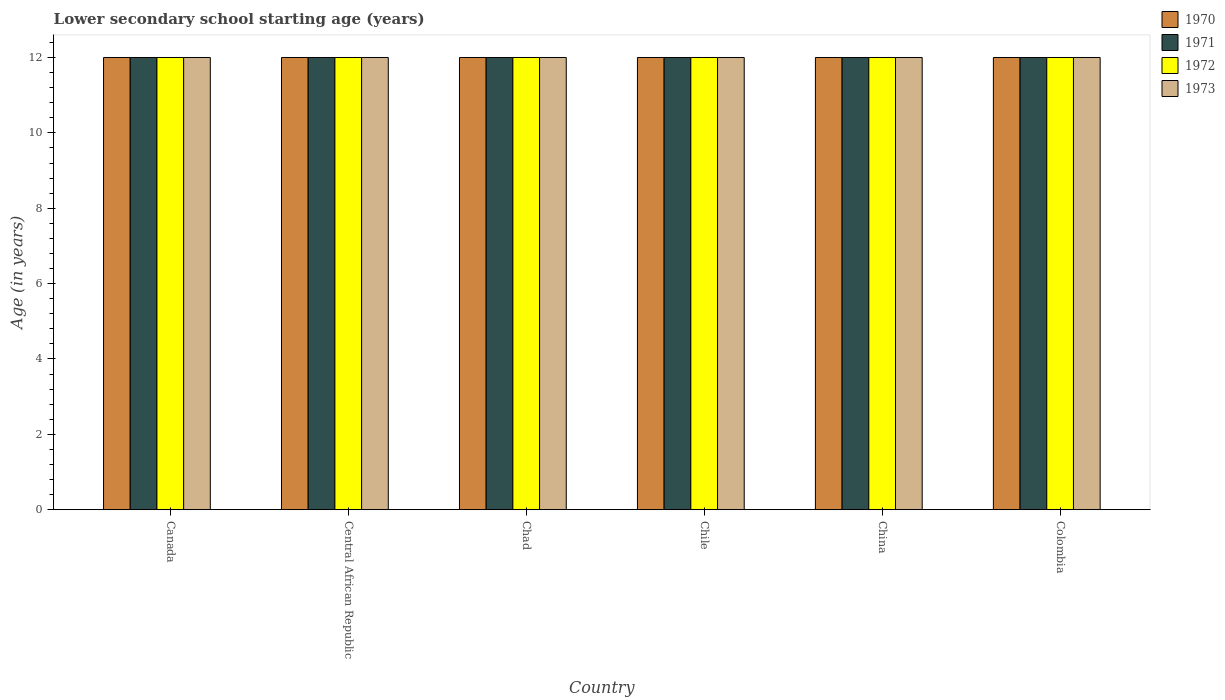How many different coloured bars are there?
Your answer should be compact. 4. How many groups of bars are there?
Your answer should be compact. 6. In how many cases, is the number of bars for a given country not equal to the number of legend labels?
Provide a succinct answer. 0. What is the lower secondary school starting age of children in 1970 in Canada?
Your answer should be compact. 12. Across all countries, what is the maximum lower secondary school starting age of children in 1972?
Provide a short and direct response. 12. What is the total lower secondary school starting age of children in 1972 in the graph?
Give a very brief answer. 72. What is the difference between the lower secondary school starting age of children in 1973 in China and the lower secondary school starting age of children in 1971 in Chad?
Offer a very short reply. 0. What is the average lower secondary school starting age of children in 1970 per country?
Provide a succinct answer. 12. What is the difference between the lower secondary school starting age of children of/in 1973 and lower secondary school starting age of children of/in 1970 in Central African Republic?
Make the answer very short. 0. What is the ratio of the lower secondary school starting age of children in 1973 in Canada to that in Chad?
Provide a succinct answer. 1. Is the lower secondary school starting age of children in 1971 in Central African Republic less than that in China?
Offer a very short reply. No. What is the difference between the highest and the lowest lower secondary school starting age of children in 1970?
Give a very brief answer. 0. In how many countries, is the lower secondary school starting age of children in 1970 greater than the average lower secondary school starting age of children in 1970 taken over all countries?
Offer a very short reply. 0. Is it the case that in every country, the sum of the lower secondary school starting age of children in 1971 and lower secondary school starting age of children in 1972 is greater than the sum of lower secondary school starting age of children in 1973 and lower secondary school starting age of children in 1970?
Your response must be concise. No. What does the 3rd bar from the left in Canada represents?
Your answer should be very brief. 1972. What does the 3rd bar from the right in Chile represents?
Make the answer very short. 1971. Are all the bars in the graph horizontal?
Your answer should be very brief. No. How many countries are there in the graph?
Provide a succinct answer. 6. What is the difference between two consecutive major ticks on the Y-axis?
Ensure brevity in your answer.  2. Does the graph contain any zero values?
Provide a short and direct response. No. Does the graph contain grids?
Keep it short and to the point. No. What is the title of the graph?
Make the answer very short. Lower secondary school starting age (years). Does "1964" appear as one of the legend labels in the graph?
Offer a very short reply. No. What is the label or title of the X-axis?
Provide a succinct answer. Country. What is the label or title of the Y-axis?
Provide a short and direct response. Age (in years). What is the Age (in years) of 1971 in Canada?
Your answer should be very brief. 12. What is the Age (in years) in 1973 in Canada?
Ensure brevity in your answer.  12. What is the Age (in years) of 1970 in Central African Republic?
Keep it short and to the point. 12. What is the Age (in years) of 1971 in Chad?
Provide a short and direct response. 12. What is the Age (in years) of 1973 in Chad?
Your response must be concise. 12. What is the Age (in years) in 1970 in Chile?
Provide a short and direct response. 12. What is the Age (in years) of 1972 in Chile?
Make the answer very short. 12. What is the Age (in years) of 1971 in China?
Provide a short and direct response. 12. What is the Age (in years) in 1973 in China?
Keep it short and to the point. 12. What is the Age (in years) in 1970 in Colombia?
Your answer should be compact. 12. What is the Age (in years) in 1971 in Colombia?
Offer a very short reply. 12. Across all countries, what is the maximum Age (in years) of 1971?
Ensure brevity in your answer.  12. Across all countries, what is the maximum Age (in years) in 1973?
Ensure brevity in your answer.  12. Across all countries, what is the minimum Age (in years) in 1972?
Provide a short and direct response. 12. Across all countries, what is the minimum Age (in years) in 1973?
Your answer should be compact. 12. What is the total Age (in years) in 1970 in the graph?
Offer a terse response. 72. What is the total Age (in years) in 1972 in the graph?
Offer a terse response. 72. What is the total Age (in years) in 1973 in the graph?
Offer a terse response. 72. What is the difference between the Age (in years) of 1970 in Canada and that in Central African Republic?
Your answer should be compact. 0. What is the difference between the Age (in years) of 1971 in Canada and that in Chad?
Offer a very short reply. 0. What is the difference between the Age (in years) of 1973 in Canada and that in Chad?
Offer a terse response. 0. What is the difference between the Age (in years) in 1970 in Canada and that in China?
Make the answer very short. 0. What is the difference between the Age (in years) in 1971 in Canada and that in China?
Offer a very short reply. 0. What is the difference between the Age (in years) of 1972 in Canada and that in China?
Keep it short and to the point. 0. What is the difference between the Age (in years) in 1970 in Canada and that in Colombia?
Offer a terse response. 0. What is the difference between the Age (in years) in 1971 in Canada and that in Colombia?
Give a very brief answer. 0. What is the difference between the Age (in years) in 1972 in Canada and that in Colombia?
Your answer should be very brief. 0. What is the difference between the Age (in years) in 1973 in Canada and that in Colombia?
Ensure brevity in your answer.  0. What is the difference between the Age (in years) in 1970 in Central African Republic and that in Chad?
Give a very brief answer. 0. What is the difference between the Age (in years) of 1971 in Central African Republic and that in Chad?
Ensure brevity in your answer.  0. What is the difference between the Age (in years) of 1972 in Central African Republic and that in Chad?
Your answer should be compact. 0. What is the difference between the Age (in years) of 1973 in Central African Republic and that in Chad?
Provide a short and direct response. 0. What is the difference between the Age (in years) of 1973 in Central African Republic and that in Colombia?
Offer a very short reply. 0. What is the difference between the Age (in years) in 1970 in Chad and that in Chile?
Ensure brevity in your answer.  0. What is the difference between the Age (in years) in 1971 in Chad and that in Chile?
Provide a succinct answer. 0. What is the difference between the Age (in years) of 1973 in Chad and that in Chile?
Keep it short and to the point. 0. What is the difference between the Age (in years) of 1970 in Chad and that in China?
Keep it short and to the point. 0. What is the difference between the Age (in years) in 1972 in Chad and that in China?
Keep it short and to the point. 0. What is the difference between the Age (in years) in 1970 in Chad and that in Colombia?
Make the answer very short. 0. What is the difference between the Age (in years) in 1971 in Chile and that in China?
Provide a succinct answer. 0. What is the difference between the Age (in years) of 1972 in Chile and that in China?
Provide a succinct answer. 0. What is the difference between the Age (in years) in 1972 in Chile and that in Colombia?
Your response must be concise. 0. What is the difference between the Age (in years) in 1973 in Chile and that in Colombia?
Provide a succinct answer. 0. What is the difference between the Age (in years) in 1972 in China and that in Colombia?
Give a very brief answer. 0. What is the difference between the Age (in years) in 1970 in Canada and the Age (in years) in 1971 in Central African Republic?
Your response must be concise. 0. What is the difference between the Age (in years) of 1971 in Canada and the Age (in years) of 1973 in Central African Republic?
Ensure brevity in your answer.  0. What is the difference between the Age (in years) of 1970 in Canada and the Age (in years) of 1973 in Chad?
Make the answer very short. 0. What is the difference between the Age (in years) of 1971 in Canada and the Age (in years) of 1972 in Chad?
Your answer should be very brief. 0. What is the difference between the Age (in years) of 1971 in Canada and the Age (in years) of 1973 in Chad?
Give a very brief answer. 0. What is the difference between the Age (in years) of 1972 in Canada and the Age (in years) of 1973 in Chad?
Make the answer very short. 0. What is the difference between the Age (in years) of 1970 in Canada and the Age (in years) of 1972 in Chile?
Provide a short and direct response. 0. What is the difference between the Age (in years) of 1971 in Canada and the Age (in years) of 1972 in Chile?
Keep it short and to the point. 0. What is the difference between the Age (in years) in 1971 in Canada and the Age (in years) in 1973 in Chile?
Your response must be concise. 0. What is the difference between the Age (in years) in 1970 in Canada and the Age (in years) in 1972 in China?
Offer a very short reply. 0. What is the difference between the Age (in years) of 1971 in Canada and the Age (in years) of 1972 in China?
Provide a succinct answer. 0. What is the difference between the Age (in years) in 1972 in Canada and the Age (in years) in 1973 in China?
Give a very brief answer. 0. What is the difference between the Age (in years) in 1970 in Canada and the Age (in years) in 1973 in Colombia?
Provide a succinct answer. 0. What is the difference between the Age (in years) in 1970 in Central African Republic and the Age (in years) in 1971 in Chad?
Provide a succinct answer. 0. What is the difference between the Age (in years) of 1970 in Central African Republic and the Age (in years) of 1973 in Chad?
Ensure brevity in your answer.  0. What is the difference between the Age (in years) in 1971 in Central African Republic and the Age (in years) in 1973 in Chad?
Offer a terse response. 0. What is the difference between the Age (in years) in 1971 in Central African Republic and the Age (in years) in 1972 in Chile?
Offer a very short reply. 0. What is the difference between the Age (in years) of 1971 in Central African Republic and the Age (in years) of 1973 in Chile?
Your response must be concise. 0. What is the difference between the Age (in years) in 1970 in Central African Republic and the Age (in years) in 1971 in China?
Keep it short and to the point. 0. What is the difference between the Age (in years) of 1970 in Central African Republic and the Age (in years) of 1972 in China?
Keep it short and to the point. 0. What is the difference between the Age (in years) of 1971 in Central African Republic and the Age (in years) of 1973 in China?
Provide a succinct answer. 0. What is the difference between the Age (in years) of 1972 in Central African Republic and the Age (in years) of 1973 in China?
Keep it short and to the point. 0. What is the difference between the Age (in years) in 1970 in Central African Republic and the Age (in years) in 1971 in Colombia?
Your answer should be very brief. 0. What is the difference between the Age (in years) in 1971 in Central African Republic and the Age (in years) in 1972 in Colombia?
Ensure brevity in your answer.  0. What is the difference between the Age (in years) in 1972 in Central African Republic and the Age (in years) in 1973 in Colombia?
Your answer should be compact. 0. What is the difference between the Age (in years) of 1970 in Chad and the Age (in years) of 1971 in Chile?
Give a very brief answer. 0. What is the difference between the Age (in years) of 1970 in Chad and the Age (in years) of 1972 in Chile?
Give a very brief answer. 0. What is the difference between the Age (in years) in 1971 in Chad and the Age (in years) in 1972 in Chile?
Offer a terse response. 0. What is the difference between the Age (in years) of 1972 in Chad and the Age (in years) of 1973 in Chile?
Your response must be concise. 0. What is the difference between the Age (in years) of 1970 in Chad and the Age (in years) of 1972 in China?
Give a very brief answer. 0. What is the difference between the Age (in years) of 1971 in Chad and the Age (in years) of 1972 in China?
Your answer should be very brief. 0. What is the difference between the Age (in years) in 1972 in Chad and the Age (in years) in 1973 in China?
Your response must be concise. 0. What is the difference between the Age (in years) in 1970 in Chad and the Age (in years) in 1972 in Colombia?
Your answer should be very brief. 0. What is the difference between the Age (in years) in 1970 in Chad and the Age (in years) in 1973 in Colombia?
Give a very brief answer. 0. What is the difference between the Age (in years) in 1971 in Chad and the Age (in years) in 1972 in Colombia?
Provide a short and direct response. 0. What is the difference between the Age (in years) of 1972 in Chad and the Age (in years) of 1973 in Colombia?
Offer a very short reply. 0. What is the difference between the Age (in years) in 1970 in Chile and the Age (in years) in 1971 in China?
Give a very brief answer. 0. What is the difference between the Age (in years) in 1970 in Chile and the Age (in years) in 1972 in China?
Provide a succinct answer. 0. What is the difference between the Age (in years) of 1970 in Chile and the Age (in years) of 1972 in Colombia?
Make the answer very short. 0. What is the difference between the Age (in years) of 1971 in Chile and the Age (in years) of 1972 in Colombia?
Offer a terse response. 0. What is the difference between the Age (in years) of 1971 in Chile and the Age (in years) of 1973 in Colombia?
Ensure brevity in your answer.  0. What is the difference between the Age (in years) in 1972 in Chile and the Age (in years) in 1973 in Colombia?
Provide a succinct answer. 0. What is the difference between the Age (in years) of 1970 in China and the Age (in years) of 1972 in Colombia?
Your answer should be compact. 0. What is the difference between the Age (in years) of 1970 in China and the Age (in years) of 1973 in Colombia?
Keep it short and to the point. 0. What is the difference between the Age (in years) of 1971 in China and the Age (in years) of 1973 in Colombia?
Your answer should be very brief. 0. What is the difference between the Age (in years) in 1972 in China and the Age (in years) in 1973 in Colombia?
Your response must be concise. 0. What is the average Age (in years) in 1971 per country?
Provide a succinct answer. 12. What is the average Age (in years) of 1972 per country?
Provide a succinct answer. 12. What is the difference between the Age (in years) in 1970 and Age (in years) in 1971 in Canada?
Offer a terse response. 0. What is the difference between the Age (in years) of 1970 and Age (in years) of 1972 in Canada?
Your answer should be compact. 0. What is the difference between the Age (in years) of 1971 and Age (in years) of 1972 in Canada?
Your response must be concise. 0. What is the difference between the Age (in years) in 1970 and Age (in years) in 1971 in Central African Republic?
Provide a succinct answer. 0. What is the difference between the Age (in years) in 1970 and Age (in years) in 1973 in Central African Republic?
Keep it short and to the point. 0. What is the difference between the Age (in years) of 1970 and Age (in years) of 1971 in Chad?
Ensure brevity in your answer.  0. What is the difference between the Age (in years) of 1970 and Age (in years) of 1973 in Chad?
Make the answer very short. 0. What is the difference between the Age (in years) in 1971 and Age (in years) in 1973 in Chad?
Offer a terse response. 0. What is the difference between the Age (in years) in 1970 and Age (in years) in 1973 in Chile?
Your answer should be very brief. 0. What is the difference between the Age (in years) of 1971 and Age (in years) of 1973 in Chile?
Make the answer very short. 0. What is the difference between the Age (in years) of 1972 and Age (in years) of 1973 in Chile?
Give a very brief answer. 0. What is the difference between the Age (in years) in 1970 and Age (in years) in 1971 in China?
Your response must be concise. 0. What is the difference between the Age (in years) in 1970 and Age (in years) in 1972 in China?
Your response must be concise. 0. What is the difference between the Age (in years) in 1971 and Age (in years) in 1973 in China?
Give a very brief answer. 0. What is the difference between the Age (in years) of 1970 and Age (in years) of 1972 in Colombia?
Keep it short and to the point. 0. What is the difference between the Age (in years) of 1970 and Age (in years) of 1973 in Colombia?
Give a very brief answer. 0. What is the difference between the Age (in years) of 1972 and Age (in years) of 1973 in Colombia?
Ensure brevity in your answer.  0. What is the ratio of the Age (in years) in 1972 in Canada to that in Central African Republic?
Offer a very short reply. 1. What is the ratio of the Age (in years) of 1970 in Canada to that in Chad?
Offer a very short reply. 1. What is the ratio of the Age (in years) of 1971 in Canada to that in Chad?
Offer a terse response. 1. What is the ratio of the Age (in years) in 1971 in Canada to that in Chile?
Make the answer very short. 1. What is the ratio of the Age (in years) in 1972 in Canada to that in Chile?
Your answer should be very brief. 1. What is the ratio of the Age (in years) in 1973 in Canada to that in Chile?
Offer a very short reply. 1. What is the ratio of the Age (in years) of 1970 in Canada to that in China?
Your answer should be compact. 1. What is the ratio of the Age (in years) of 1973 in Canada to that in China?
Ensure brevity in your answer.  1. What is the ratio of the Age (in years) in 1973 in Canada to that in Colombia?
Provide a succinct answer. 1. What is the ratio of the Age (in years) in 1972 in Central African Republic to that in Chad?
Offer a very short reply. 1. What is the ratio of the Age (in years) of 1970 in Central African Republic to that in Chile?
Your response must be concise. 1. What is the ratio of the Age (in years) of 1972 in Central African Republic to that in Chile?
Make the answer very short. 1. What is the ratio of the Age (in years) in 1971 in Central African Republic to that in China?
Offer a very short reply. 1. What is the ratio of the Age (in years) in 1972 in Central African Republic to that in China?
Provide a succinct answer. 1. What is the ratio of the Age (in years) of 1973 in Central African Republic to that in China?
Your response must be concise. 1. What is the ratio of the Age (in years) in 1971 in Central African Republic to that in Colombia?
Make the answer very short. 1. What is the ratio of the Age (in years) of 1972 in Central African Republic to that in Colombia?
Offer a very short reply. 1. What is the ratio of the Age (in years) of 1973 in Central African Republic to that in Colombia?
Your answer should be compact. 1. What is the ratio of the Age (in years) of 1970 in Chad to that in Chile?
Make the answer very short. 1. What is the ratio of the Age (in years) of 1973 in Chad to that in Chile?
Give a very brief answer. 1. What is the ratio of the Age (in years) of 1970 in Chad to that in China?
Your response must be concise. 1. What is the ratio of the Age (in years) in 1972 in Chad to that in China?
Your response must be concise. 1. What is the ratio of the Age (in years) of 1970 in Chad to that in Colombia?
Your response must be concise. 1. What is the ratio of the Age (in years) in 1971 in Chad to that in Colombia?
Your response must be concise. 1. What is the ratio of the Age (in years) in 1971 in Chile to that in China?
Provide a short and direct response. 1. What is the ratio of the Age (in years) of 1972 in Chile to that in China?
Keep it short and to the point. 1. What is the ratio of the Age (in years) in 1973 in Chile to that in China?
Your answer should be very brief. 1. What is the ratio of the Age (in years) in 1970 in Chile to that in Colombia?
Provide a short and direct response. 1. What is the ratio of the Age (in years) in 1971 in Chile to that in Colombia?
Provide a succinct answer. 1. What is the ratio of the Age (in years) in 1972 in Chile to that in Colombia?
Provide a short and direct response. 1. What is the ratio of the Age (in years) of 1972 in China to that in Colombia?
Offer a terse response. 1. What is the difference between the highest and the second highest Age (in years) of 1970?
Provide a short and direct response. 0. What is the difference between the highest and the second highest Age (in years) of 1973?
Provide a succinct answer. 0. What is the difference between the highest and the lowest Age (in years) of 1973?
Your answer should be compact. 0. 